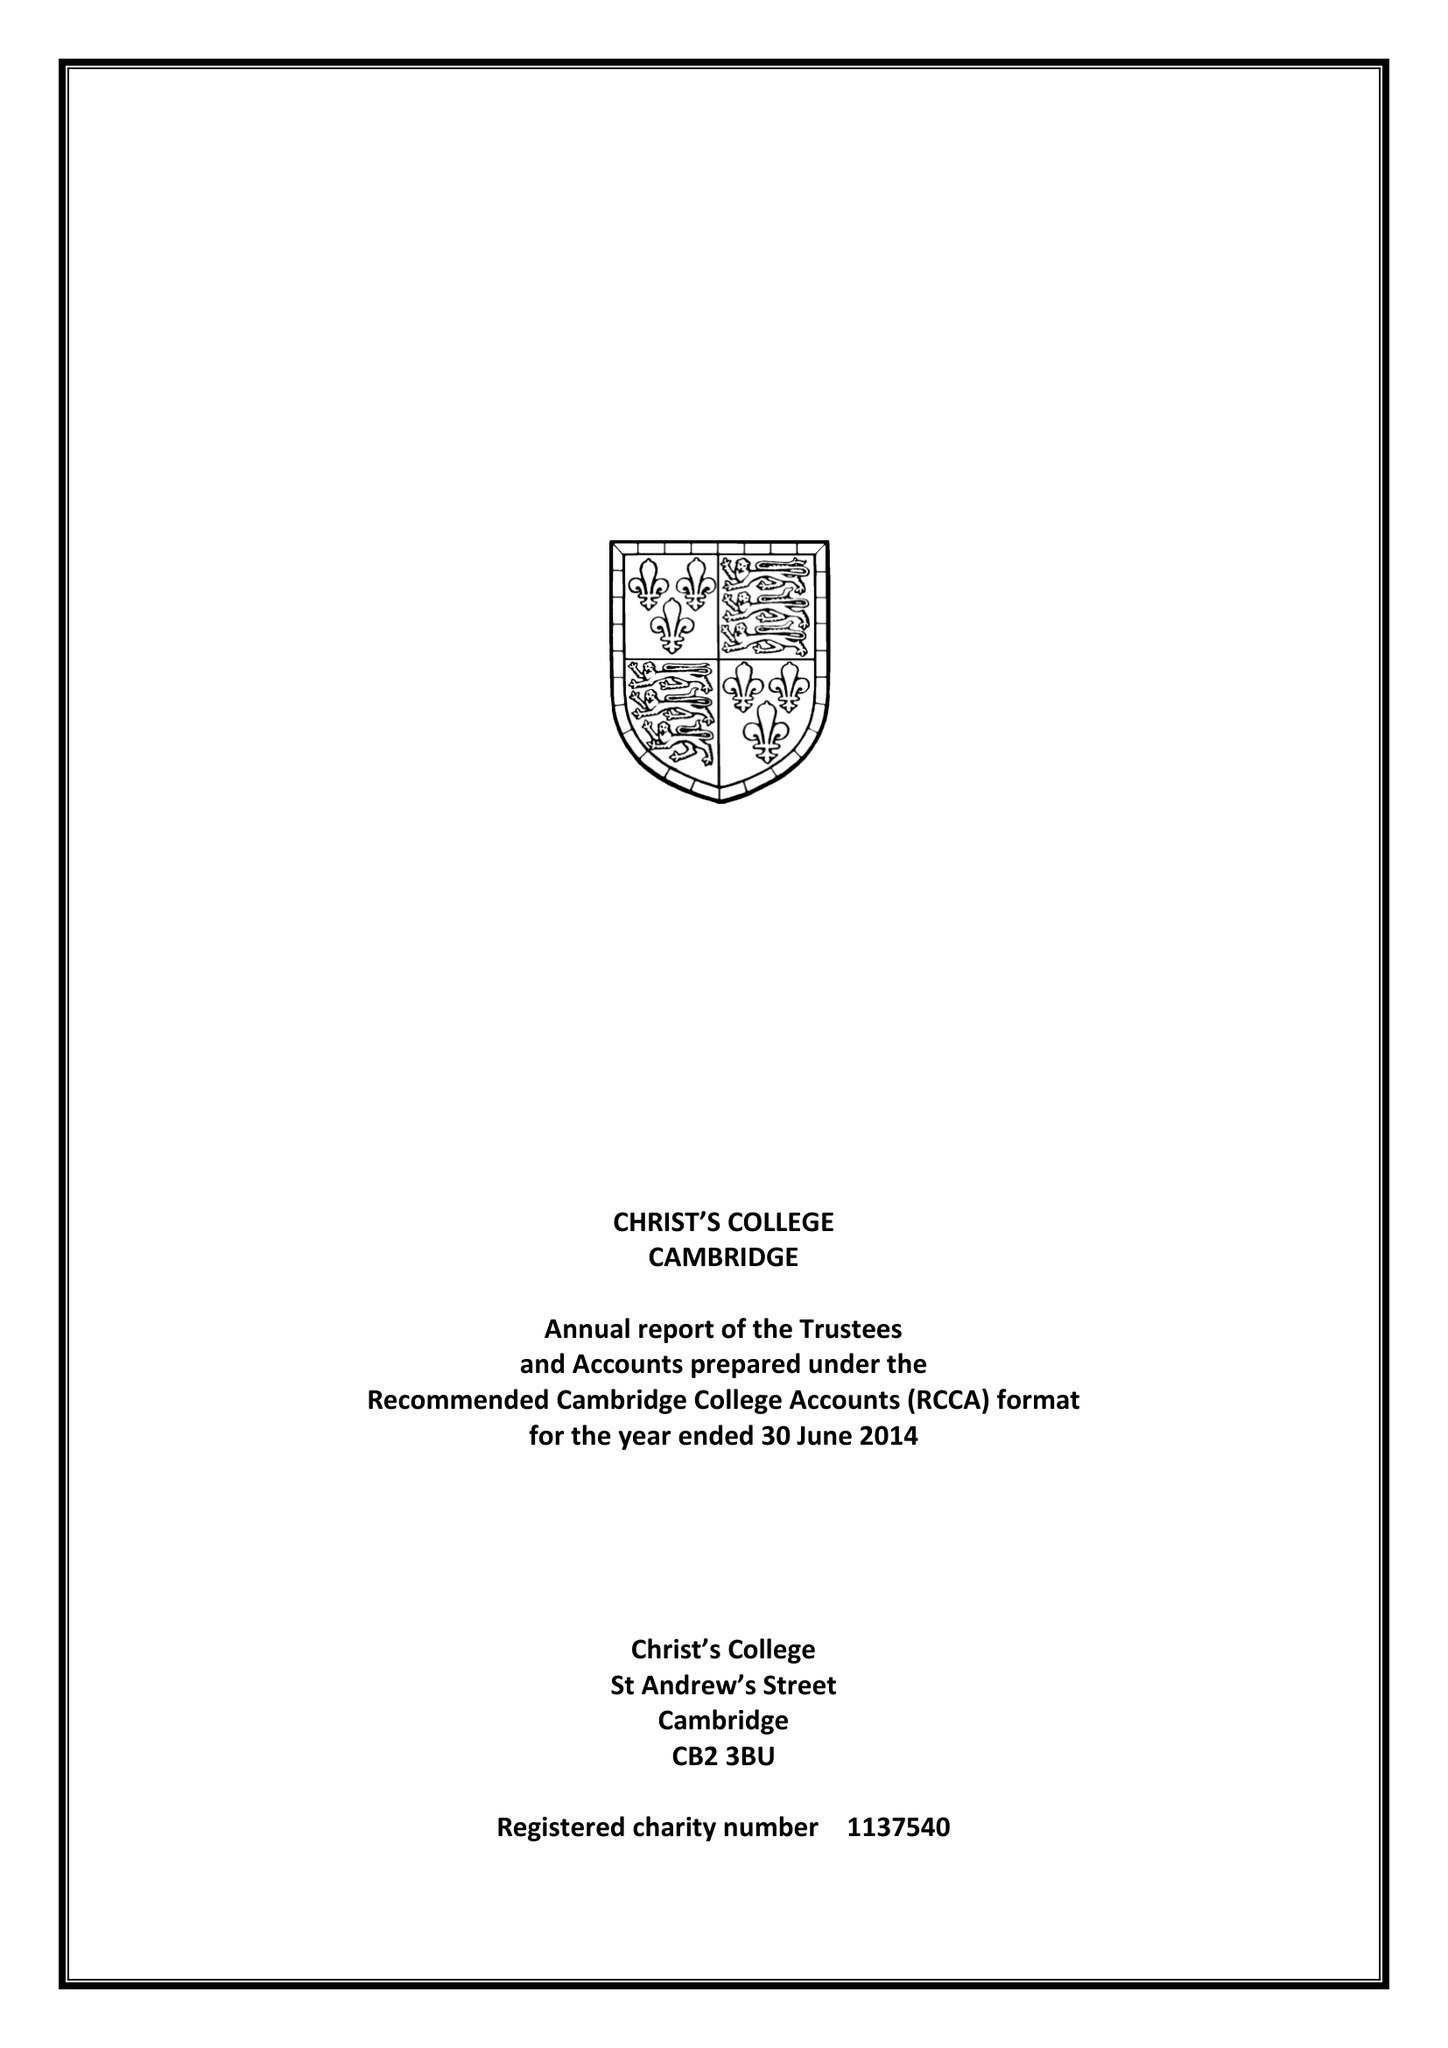What is the value for the address__street_line?
Answer the question using a single word or phrase. ST ANDREW'S STREET 